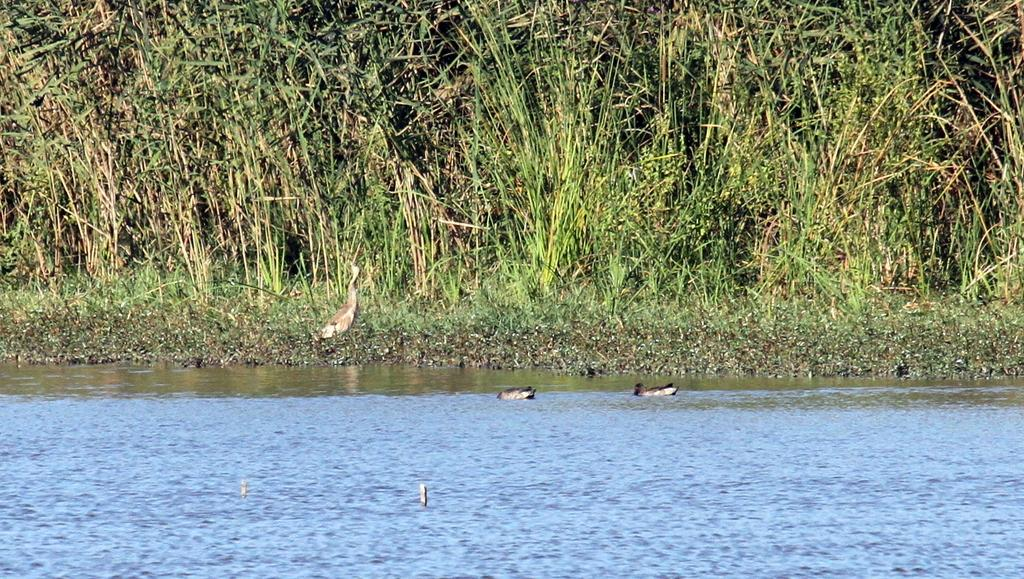What type of animals can be seen in the image? There are birds in the image. What can be seen in the background of the image? There is grass in the background of the image. What is visible at the bottom of the image? There is water visible at the bottom of the image. What type of shoes are the secretary wearing in the image? There is no secretary or shoes present in the image; it features birds, grass, and water. 